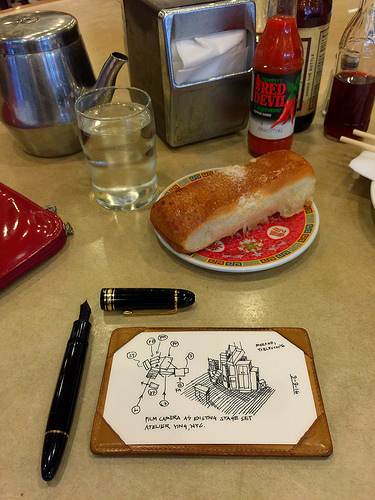<image>
Can you confirm if the sauce is in the jar? No. The sauce is not contained within the jar. These objects have a different spatial relationship. 